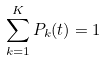Convert formula to latex. <formula><loc_0><loc_0><loc_500><loc_500>\sum _ { k = 1 } ^ { K } P _ { k } ( t ) = 1</formula> 